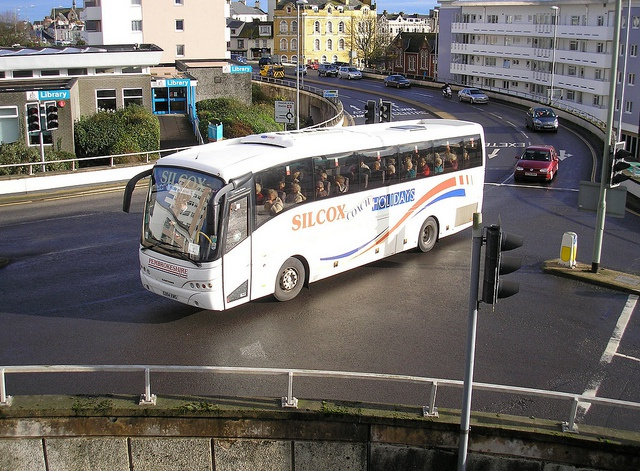Describe the objects in this image and their specific colors. I can see bus in darkgray, white, gray, and black tones, traffic light in darkgray, black, and gray tones, car in darkgray, black, gray, maroon, and purple tones, car in darkgray, black, gray, navy, and darkblue tones, and traffic light in darkgray, black, gray, and lightgray tones in this image. 